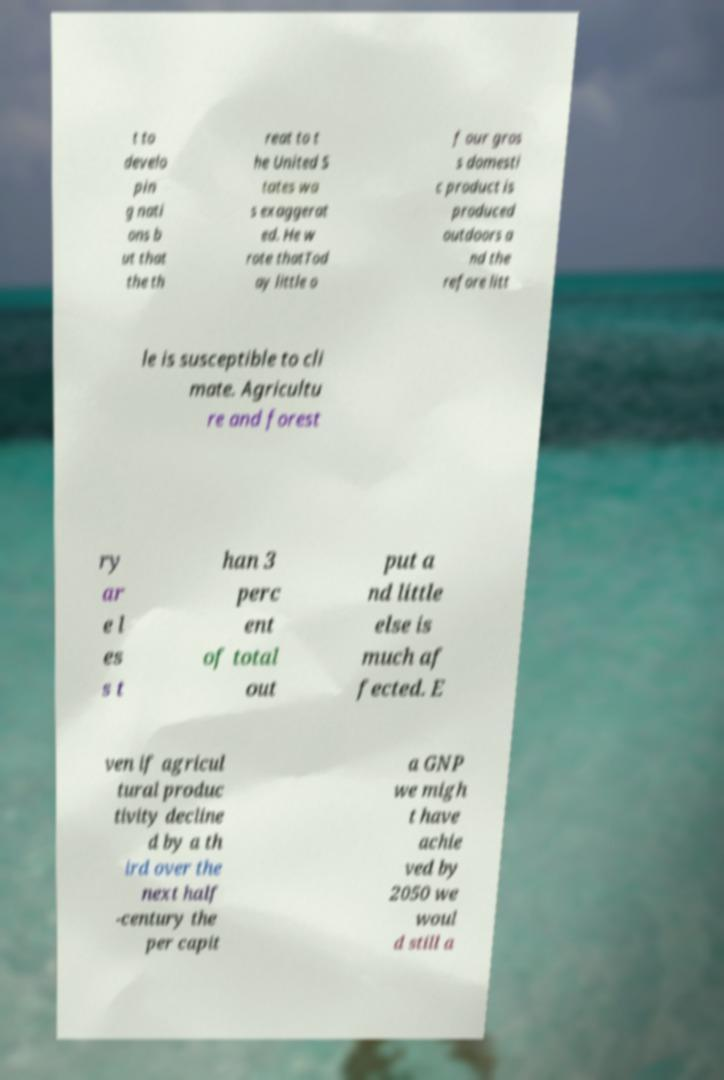I need the written content from this picture converted into text. Can you do that? t to develo pin g nati ons b ut that the th reat to t he United S tates wa s exaggerat ed. He w rote thatTod ay little o f our gros s domesti c product is produced outdoors a nd the refore litt le is susceptible to cli mate. Agricultu re and forest ry ar e l es s t han 3 perc ent of total out put a nd little else is much af fected. E ven if agricul tural produc tivity decline d by a th ird over the next half -century the per capit a GNP we migh t have achie ved by 2050 we woul d still a 